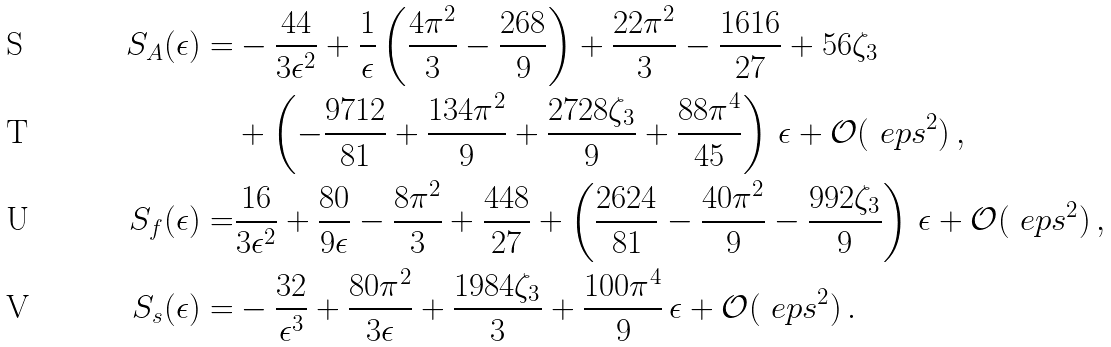Convert formula to latex. <formula><loc_0><loc_0><loc_500><loc_500>S _ { A } ( \epsilon ) = & - \frac { 4 4 } { 3 \epsilon ^ { 2 } } + \frac { 1 } { \epsilon } \left ( \frac { 4 \pi ^ { 2 } } { 3 } - \frac { 2 6 8 } { 9 } \right ) + \frac { 2 2 \pi ^ { 2 } } { 3 } - \frac { 1 6 1 6 } { 2 7 } + 5 6 \zeta _ { 3 } \\ & + \left ( - \frac { 9 7 1 2 } { 8 1 } + \frac { 1 3 4 \pi ^ { 2 } } { 9 } + \frac { 2 7 2 8 \zeta _ { 3 } } { 9 } + \frac { 8 8 \pi ^ { 4 } } { 4 5 } \right ) \, \epsilon + \mathcal { O } ( \ e p s ^ { 2 } ) \, , \\ S _ { f } ( \epsilon ) = & \frac { 1 6 } { 3 \epsilon ^ { 2 } } + \frac { 8 0 } { 9 \epsilon } - \frac { 8 \pi ^ { 2 } } { 3 } + \frac { 4 4 8 } { 2 7 } + \left ( \frac { 2 6 2 4 } { 8 1 } - \frac { 4 0 \pi ^ { 2 } } { 9 } - \frac { 9 9 2 \zeta _ { 3 } } { 9 } \right ) \, \epsilon + \mathcal { O } ( \ e p s ^ { 2 } ) \, , \\ S _ { s } ( \epsilon ) = & - \frac { 3 2 } { \epsilon ^ { 3 } } + \frac { 8 0 \pi ^ { 2 } } { 3 \epsilon } + \frac { 1 9 8 4 \zeta _ { 3 } } { 3 } + \frac { 1 0 0 \pi ^ { 4 } } { 9 } \, \epsilon + \mathcal { O } ( \ e p s ^ { 2 } ) \, .</formula> 